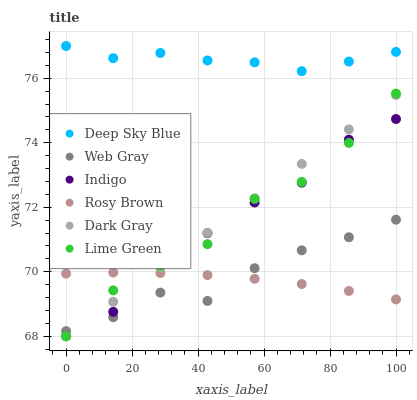Does Rosy Brown have the minimum area under the curve?
Answer yes or no. Yes. Does Deep Sky Blue have the maximum area under the curve?
Answer yes or no. Yes. Does Indigo have the minimum area under the curve?
Answer yes or no. No. Does Indigo have the maximum area under the curve?
Answer yes or no. No. Is Dark Gray the smoothest?
Answer yes or no. Yes. Is Indigo the roughest?
Answer yes or no. Yes. Is Rosy Brown the smoothest?
Answer yes or no. No. Is Rosy Brown the roughest?
Answer yes or no. No. Does Indigo have the lowest value?
Answer yes or no. Yes. Does Rosy Brown have the lowest value?
Answer yes or no. No. Does Deep Sky Blue have the highest value?
Answer yes or no. Yes. Does Indigo have the highest value?
Answer yes or no. No. Is Web Gray less than Deep Sky Blue?
Answer yes or no. Yes. Is Deep Sky Blue greater than Lime Green?
Answer yes or no. Yes. Does Web Gray intersect Lime Green?
Answer yes or no. Yes. Is Web Gray less than Lime Green?
Answer yes or no. No. Is Web Gray greater than Lime Green?
Answer yes or no. No. Does Web Gray intersect Deep Sky Blue?
Answer yes or no. No. 